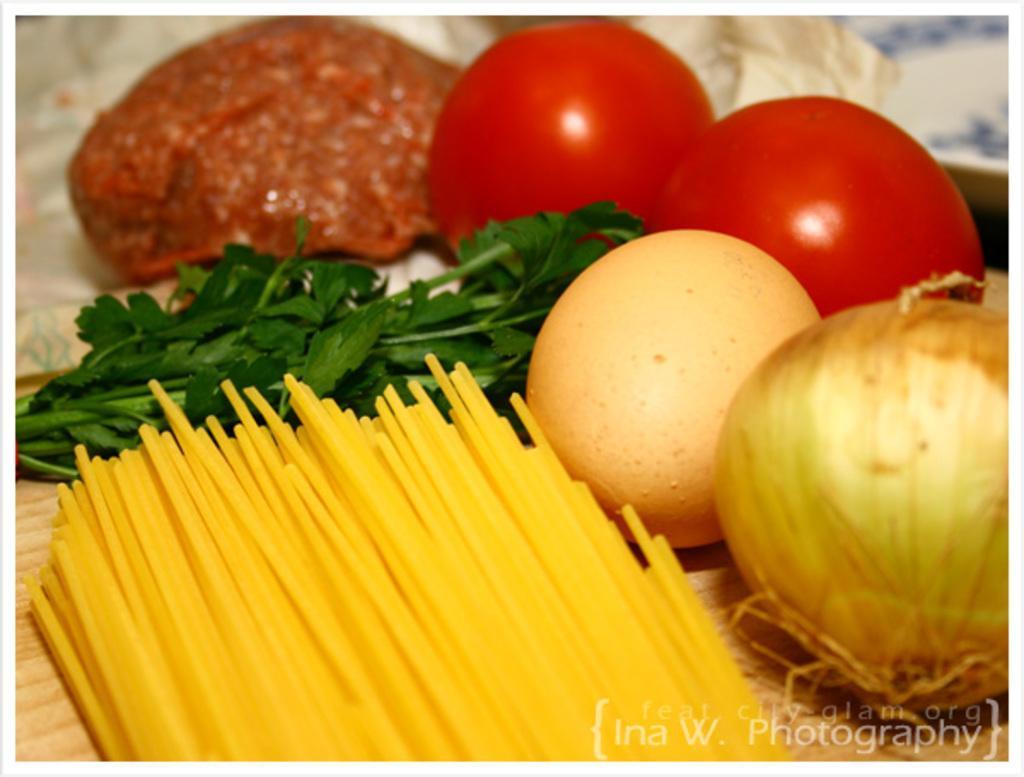Please provide a concise description of this image. In this image we can see raw meat, vegetables, egg, spaghetti and leaves on the wooden surface. 